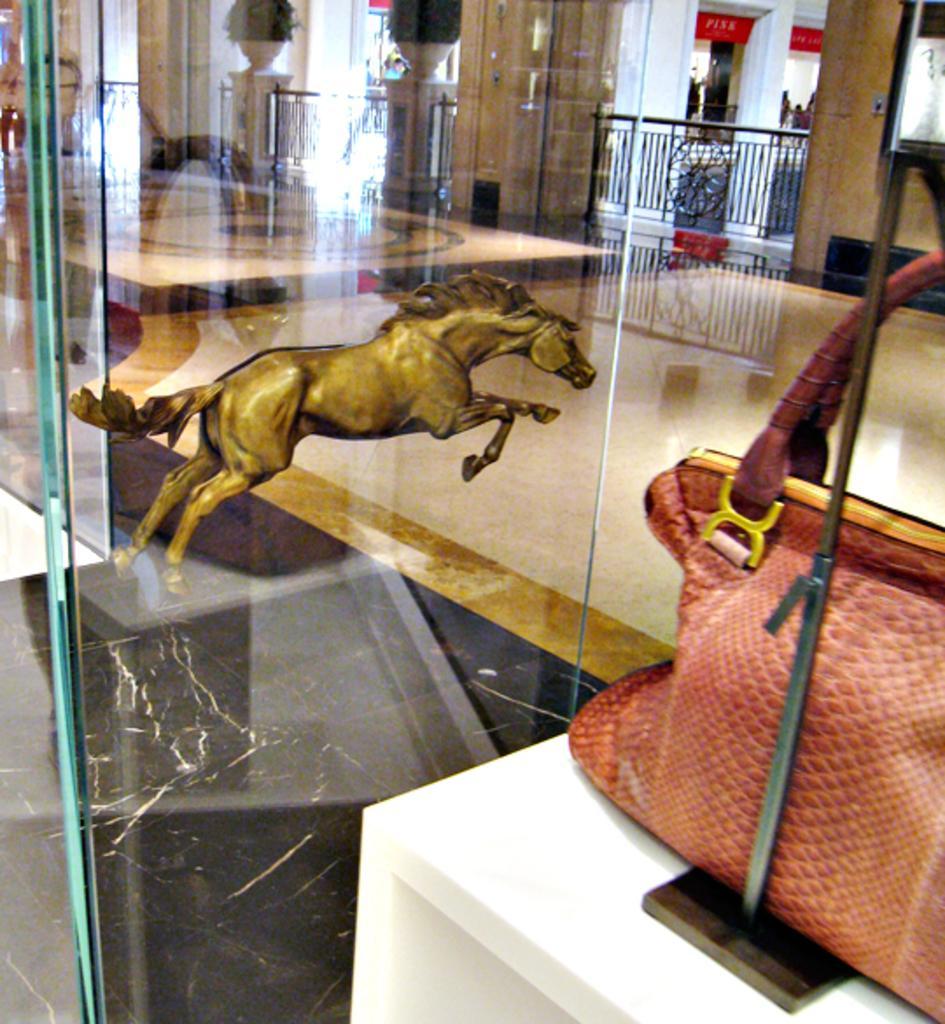Describe this image in one or two sentences. In the center of the image we can see a sculpture placed on the ground. To the right side of the image we can see a bag and pole placed on the table. In the background, we can see railings, pillars, plants, some persons are standing on the floor and signboards with some text. 